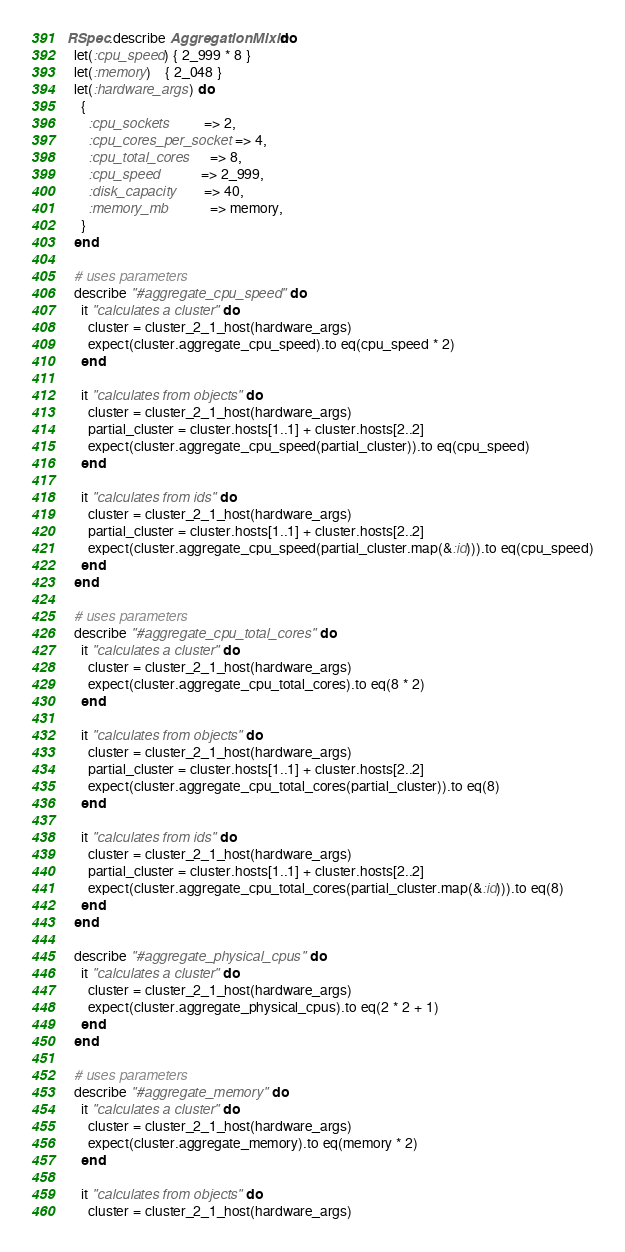<code> <loc_0><loc_0><loc_500><loc_500><_Ruby_>RSpec.describe AggregationMixin do
  let(:cpu_speed) { 2_999 * 8 }
  let(:memory)    { 2_048 }
  let(:hardware_args) do
    {
      :cpu_sockets          => 2,
      :cpu_cores_per_socket => 4,
      :cpu_total_cores      => 8,
      :cpu_speed            => 2_999,
      :disk_capacity        => 40,
      :memory_mb            => memory,
    }
  end

  # uses parameters
  describe "#aggregate_cpu_speed" do
    it "calculates a cluster" do
      cluster = cluster_2_1_host(hardware_args)
      expect(cluster.aggregate_cpu_speed).to eq(cpu_speed * 2)
    end

    it "calculates from objects" do
      cluster = cluster_2_1_host(hardware_args)
      partial_cluster = cluster.hosts[1..1] + cluster.hosts[2..2]
      expect(cluster.aggregate_cpu_speed(partial_cluster)).to eq(cpu_speed)
    end

    it "calculates from ids" do
      cluster = cluster_2_1_host(hardware_args)
      partial_cluster = cluster.hosts[1..1] + cluster.hosts[2..2]
      expect(cluster.aggregate_cpu_speed(partial_cluster.map(&:id))).to eq(cpu_speed)
    end
  end

  # uses parameters
  describe "#aggregate_cpu_total_cores" do
    it "calculates a cluster" do
      cluster = cluster_2_1_host(hardware_args)
      expect(cluster.aggregate_cpu_total_cores).to eq(8 * 2)
    end

    it "calculates from objects" do
      cluster = cluster_2_1_host(hardware_args)
      partial_cluster = cluster.hosts[1..1] + cluster.hosts[2..2]
      expect(cluster.aggregate_cpu_total_cores(partial_cluster)).to eq(8)
    end

    it "calculates from ids" do
      cluster = cluster_2_1_host(hardware_args)
      partial_cluster = cluster.hosts[1..1] + cluster.hosts[2..2]
      expect(cluster.aggregate_cpu_total_cores(partial_cluster.map(&:id))).to eq(8)
    end
  end

  describe "#aggregate_physical_cpus" do
    it "calculates a cluster" do
      cluster = cluster_2_1_host(hardware_args)
      expect(cluster.aggregate_physical_cpus).to eq(2 * 2 + 1)
    end
  end

  # uses parameters
  describe "#aggregate_memory" do
    it "calculates a cluster" do
      cluster = cluster_2_1_host(hardware_args)
      expect(cluster.aggregate_memory).to eq(memory * 2)
    end

    it "calculates from objects" do
      cluster = cluster_2_1_host(hardware_args)</code> 